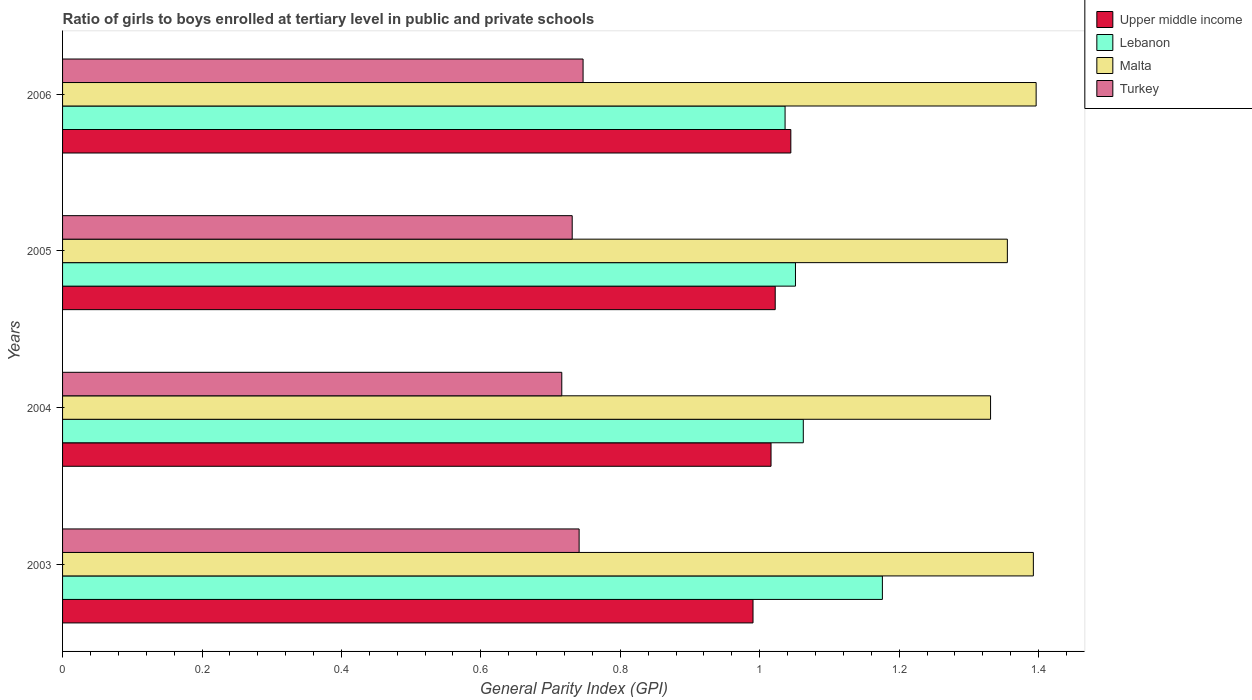How many bars are there on the 3rd tick from the top?
Provide a short and direct response. 4. What is the label of the 4th group of bars from the top?
Your response must be concise. 2003. What is the general parity index in Turkey in 2003?
Give a very brief answer. 0.74. Across all years, what is the maximum general parity index in Turkey?
Keep it short and to the point. 0.75. Across all years, what is the minimum general parity index in Turkey?
Your answer should be very brief. 0.72. What is the total general parity index in Lebanon in the graph?
Give a very brief answer. 4.33. What is the difference between the general parity index in Upper middle income in 2003 and that in 2004?
Provide a short and direct response. -0.03. What is the difference between the general parity index in Upper middle income in 2004 and the general parity index in Turkey in 2006?
Offer a terse response. 0.27. What is the average general parity index in Upper middle income per year?
Give a very brief answer. 1.02. In the year 2006, what is the difference between the general parity index in Lebanon and general parity index in Upper middle income?
Make the answer very short. -0.01. What is the ratio of the general parity index in Turkey in 2004 to that in 2005?
Provide a succinct answer. 0.98. Is the difference between the general parity index in Lebanon in 2003 and 2004 greater than the difference between the general parity index in Upper middle income in 2003 and 2004?
Ensure brevity in your answer.  Yes. What is the difference between the highest and the second highest general parity index in Malta?
Ensure brevity in your answer.  0. What is the difference between the highest and the lowest general parity index in Turkey?
Make the answer very short. 0.03. In how many years, is the general parity index in Turkey greater than the average general parity index in Turkey taken over all years?
Provide a short and direct response. 2. Is the sum of the general parity index in Malta in 2004 and 2005 greater than the maximum general parity index in Lebanon across all years?
Provide a succinct answer. Yes. What does the 3rd bar from the top in 2003 represents?
Your answer should be compact. Lebanon. What does the 4th bar from the bottom in 2005 represents?
Give a very brief answer. Turkey. How many years are there in the graph?
Keep it short and to the point. 4. What is the difference between two consecutive major ticks on the X-axis?
Keep it short and to the point. 0.2. Does the graph contain any zero values?
Your response must be concise. No. Does the graph contain grids?
Ensure brevity in your answer.  No. Where does the legend appear in the graph?
Give a very brief answer. Top right. How many legend labels are there?
Offer a terse response. 4. What is the title of the graph?
Your answer should be compact. Ratio of girls to boys enrolled at tertiary level in public and private schools. Does "Grenada" appear as one of the legend labels in the graph?
Offer a terse response. No. What is the label or title of the X-axis?
Your answer should be very brief. General Parity Index (GPI). What is the label or title of the Y-axis?
Ensure brevity in your answer.  Years. What is the General Parity Index (GPI) in Upper middle income in 2003?
Keep it short and to the point. 0.99. What is the General Parity Index (GPI) in Lebanon in 2003?
Offer a terse response. 1.18. What is the General Parity Index (GPI) of Malta in 2003?
Provide a short and direct response. 1.39. What is the General Parity Index (GPI) of Turkey in 2003?
Ensure brevity in your answer.  0.74. What is the General Parity Index (GPI) in Upper middle income in 2004?
Offer a very short reply. 1.02. What is the General Parity Index (GPI) of Lebanon in 2004?
Make the answer very short. 1.06. What is the General Parity Index (GPI) in Malta in 2004?
Offer a terse response. 1.33. What is the General Parity Index (GPI) in Turkey in 2004?
Your answer should be very brief. 0.72. What is the General Parity Index (GPI) of Upper middle income in 2005?
Provide a succinct answer. 1.02. What is the General Parity Index (GPI) of Lebanon in 2005?
Keep it short and to the point. 1.05. What is the General Parity Index (GPI) of Malta in 2005?
Make the answer very short. 1.36. What is the General Parity Index (GPI) of Turkey in 2005?
Provide a short and direct response. 0.73. What is the General Parity Index (GPI) in Upper middle income in 2006?
Offer a terse response. 1.04. What is the General Parity Index (GPI) in Lebanon in 2006?
Keep it short and to the point. 1.04. What is the General Parity Index (GPI) in Malta in 2006?
Your answer should be compact. 1.4. What is the General Parity Index (GPI) of Turkey in 2006?
Ensure brevity in your answer.  0.75. Across all years, what is the maximum General Parity Index (GPI) in Upper middle income?
Offer a terse response. 1.04. Across all years, what is the maximum General Parity Index (GPI) in Lebanon?
Keep it short and to the point. 1.18. Across all years, what is the maximum General Parity Index (GPI) in Malta?
Provide a short and direct response. 1.4. Across all years, what is the maximum General Parity Index (GPI) in Turkey?
Provide a succinct answer. 0.75. Across all years, what is the minimum General Parity Index (GPI) of Upper middle income?
Your response must be concise. 0.99. Across all years, what is the minimum General Parity Index (GPI) in Lebanon?
Your answer should be very brief. 1.04. Across all years, what is the minimum General Parity Index (GPI) of Malta?
Your response must be concise. 1.33. Across all years, what is the minimum General Parity Index (GPI) of Turkey?
Ensure brevity in your answer.  0.72. What is the total General Parity Index (GPI) in Upper middle income in the graph?
Offer a terse response. 4.07. What is the total General Parity Index (GPI) of Lebanon in the graph?
Your response must be concise. 4.33. What is the total General Parity Index (GPI) of Malta in the graph?
Give a very brief answer. 5.48. What is the total General Parity Index (GPI) in Turkey in the graph?
Provide a short and direct response. 2.93. What is the difference between the General Parity Index (GPI) in Upper middle income in 2003 and that in 2004?
Make the answer very short. -0.03. What is the difference between the General Parity Index (GPI) in Lebanon in 2003 and that in 2004?
Provide a succinct answer. 0.11. What is the difference between the General Parity Index (GPI) of Malta in 2003 and that in 2004?
Make the answer very short. 0.06. What is the difference between the General Parity Index (GPI) in Turkey in 2003 and that in 2004?
Your response must be concise. 0.02. What is the difference between the General Parity Index (GPI) of Upper middle income in 2003 and that in 2005?
Your answer should be very brief. -0.03. What is the difference between the General Parity Index (GPI) in Lebanon in 2003 and that in 2005?
Your answer should be very brief. 0.12. What is the difference between the General Parity Index (GPI) of Malta in 2003 and that in 2005?
Ensure brevity in your answer.  0.04. What is the difference between the General Parity Index (GPI) in Turkey in 2003 and that in 2005?
Your response must be concise. 0.01. What is the difference between the General Parity Index (GPI) of Upper middle income in 2003 and that in 2006?
Your response must be concise. -0.05. What is the difference between the General Parity Index (GPI) in Lebanon in 2003 and that in 2006?
Your answer should be compact. 0.14. What is the difference between the General Parity Index (GPI) in Malta in 2003 and that in 2006?
Ensure brevity in your answer.  -0. What is the difference between the General Parity Index (GPI) of Turkey in 2003 and that in 2006?
Give a very brief answer. -0.01. What is the difference between the General Parity Index (GPI) in Upper middle income in 2004 and that in 2005?
Make the answer very short. -0.01. What is the difference between the General Parity Index (GPI) of Lebanon in 2004 and that in 2005?
Make the answer very short. 0.01. What is the difference between the General Parity Index (GPI) of Malta in 2004 and that in 2005?
Your answer should be very brief. -0.02. What is the difference between the General Parity Index (GPI) in Turkey in 2004 and that in 2005?
Offer a very short reply. -0.01. What is the difference between the General Parity Index (GPI) in Upper middle income in 2004 and that in 2006?
Your response must be concise. -0.03. What is the difference between the General Parity Index (GPI) of Lebanon in 2004 and that in 2006?
Make the answer very short. 0.03. What is the difference between the General Parity Index (GPI) in Malta in 2004 and that in 2006?
Provide a succinct answer. -0.07. What is the difference between the General Parity Index (GPI) in Turkey in 2004 and that in 2006?
Give a very brief answer. -0.03. What is the difference between the General Parity Index (GPI) in Upper middle income in 2005 and that in 2006?
Your answer should be very brief. -0.02. What is the difference between the General Parity Index (GPI) in Lebanon in 2005 and that in 2006?
Provide a short and direct response. 0.01. What is the difference between the General Parity Index (GPI) in Malta in 2005 and that in 2006?
Offer a very short reply. -0.04. What is the difference between the General Parity Index (GPI) in Turkey in 2005 and that in 2006?
Provide a short and direct response. -0.02. What is the difference between the General Parity Index (GPI) in Upper middle income in 2003 and the General Parity Index (GPI) in Lebanon in 2004?
Offer a terse response. -0.07. What is the difference between the General Parity Index (GPI) in Upper middle income in 2003 and the General Parity Index (GPI) in Malta in 2004?
Offer a terse response. -0.34. What is the difference between the General Parity Index (GPI) of Upper middle income in 2003 and the General Parity Index (GPI) of Turkey in 2004?
Make the answer very short. 0.27. What is the difference between the General Parity Index (GPI) in Lebanon in 2003 and the General Parity Index (GPI) in Malta in 2004?
Your response must be concise. -0.16. What is the difference between the General Parity Index (GPI) in Lebanon in 2003 and the General Parity Index (GPI) in Turkey in 2004?
Make the answer very short. 0.46. What is the difference between the General Parity Index (GPI) of Malta in 2003 and the General Parity Index (GPI) of Turkey in 2004?
Keep it short and to the point. 0.68. What is the difference between the General Parity Index (GPI) of Upper middle income in 2003 and the General Parity Index (GPI) of Lebanon in 2005?
Make the answer very short. -0.06. What is the difference between the General Parity Index (GPI) of Upper middle income in 2003 and the General Parity Index (GPI) of Malta in 2005?
Ensure brevity in your answer.  -0.36. What is the difference between the General Parity Index (GPI) in Upper middle income in 2003 and the General Parity Index (GPI) in Turkey in 2005?
Keep it short and to the point. 0.26. What is the difference between the General Parity Index (GPI) of Lebanon in 2003 and the General Parity Index (GPI) of Malta in 2005?
Make the answer very short. -0.18. What is the difference between the General Parity Index (GPI) of Lebanon in 2003 and the General Parity Index (GPI) of Turkey in 2005?
Your answer should be compact. 0.44. What is the difference between the General Parity Index (GPI) of Malta in 2003 and the General Parity Index (GPI) of Turkey in 2005?
Provide a short and direct response. 0.66. What is the difference between the General Parity Index (GPI) of Upper middle income in 2003 and the General Parity Index (GPI) of Lebanon in 2006?
Offer a very short reply. -0.05. What is the difference between the General Parity Index (GPI) of Upper middle income in 2003 and the General Parity Index (GPI) of Malta in 2006?
Provide a short and direct response. -0.41. What is the difference between the General Parity Index (GPI) in Upper middle income in 2003 and the General Parity Index (GPI) in Turkey in 2006?
Give a very brief answer. 0.24. What is the difference between the General Parity Index (GPI) in Lebanon in 2003 and the General Parity Index (GPI) in Malta in 2006?
Make the answer very short. -0.22. What is the difference between the General Parity Index (GPI) in Lebanon in 2003 and the General Parity Index (GPI) in Turkey in 2006?
Offer a terse response. 0.43. What is the difference between the General Parity Index (GPI) of Malta in 2003 and the General Parity Index (GPI) of Turkey in 2006?
Offer a terse response. 0.65. What is the difference between the General Parity Index (GPI) of Upper middle income in 2004 and the General Parity Index (GPI) of Lebanon in 2005?
Provide a short and direct response. -0.04. What is the difference between the General Parity Index (GPI) in Upper middle income in 2004 and the General Parity Index (GPI) in Malta in 2005?
Provide a short and direct response. -0.34. What is the difference between the General Parity Index (GPI) of Upper middle income in 2004 and the General Parity Index (GPI) of Turkey in 2005?
Provide a short and direct response. 0.29. What is the difference between the General Parity Index (GPI) in Lebanon in 2004 and the General Parity Index (GPI) in Malta in 2005?
Offer a very short reply. -0.29. What is the difference between the General Parity Index (GPI) in Lebanon in 2004 and the General Parity Index (GPI) in Turkey in 2005?
Offer a terse response. 0.33. What is the difference between the General Parity Index (GPI) in Malta in 2004 and the General Parity Index (GPI) in Turkey in 2005?
Provide a short and direct response. 0.6. What is the difference between the General Parity Index (GPI) of Upper middle income in 2004 and the General Parity Index (GPI) of Lebanon in 2006?
Keep it short and to the point. -0.02. What is the difference between the General Parity Index (GPI) in Upper middle income in 2004 and the General Parity Index (GPI) in Malta in 2006?
Offer a very short reply. -0.38. What is the difference between the General Parity Index (GPI) of Upper middle income in 2004 and the General Parity Index (GPI) of Turkey in 2006?
Keep it short and to the point. 0.27. What is the difference between the General Parity Index (GPI) of Lebanon in 2004 and the General Parity Index (GPI) of Malta in 2006?
Provide a short and direct response. -0.33. What is the difference between the General Parity Index (GPI) of Lebanon in 2004 and the General Parity Index (GPI) of Turkey in 2006?
Your answer should be compact. 0.32. What is the difference between the General Parity Index (GPI) in Malta in 2004 and the General Parity Index (GPI) in Turkey in 2006?
Provide a short and direct response. 0.58. What is the difference between the General Parity Index (GPI) in Upper middle income in 2005 and the General Parity Index (GPI) in Lebanon in 2006?
Provide a succinct answer. -0.01. What is the difference between the General Parity Index (GPI) of Upper middle income in 2005 and the General Parity Index (GPI) of Malta in 2006?
Make the answer very short. -0.37. What is the difference between the General Parity Index (GPI) of Upper middle income in 2005 and the General Parity Index (GPI) of Turkey in 2006?
Ensure brevity in your answer.  0.28. What is the difference between the General Parity Index (GPI) in Lebanon in 2005 and the General Parity Index (GPI) in Malta in 2006?
Your answer should be very brief. -0.35. What is the difference between the General Parity Index (GPI) of Lebanon in 2005 and the General Parity Index (GPI) of Turkey in 2006?
Your answer should be compact. 0.3. What is the difference between the General Parity Index (GPI) of Malta in 2005 and the General Parity Index (GPI) of Turkey in 2006?
Provide a succinct answer. 0.61. What is the average General Parity Index (GPI) in Upper middle income per year?
Your answer should be compact. 1.02. What is the average General Parity Index (GPI) of Lebanon per year?
Keep it short and to the point. 1.08. What is the average General Parity Index (GPI) of Malta per year?
Your answer should be compact. 1.37. What is the average General Parity Index (GPI) in Turkey per year?
Your answer should be compact. 0.73. In the year 2003, what is the difference between the General Parity Index (GPI) in Upper middle income and General Parity Index (GPI) in Lebanon?
Make the answer very short. -0.19. In the year 2003, what is the difference between the General Parity Index (GPI) of Upper middle income and General Parity Index (GPI) of Malta?
Your answer should be compact. -0.4. In the year 2003, what is the difference between the General Parity Index (GPI) in Upper middle income and General Parity Index (GPI) in Turkey?
Give a very brief answer. 0.25. In the year 2003, what is the difference between the General Parity Index (GPI) in Lebanon and General Parity Index (GPI) in Malta?
Provide a short and direct response. -0.22. In the year 2003, what is the difference between the General Parity Index (GPI) in Lebanon and General Parity Index (GPI) in Turkey?
Your answer should be compact. 0.43. In the year 2003, what is the difference between the General Parity Index (GPI) of Malta and General Parity Index (GPI) of Turkey?
Your response must be concise. 0.65. In the year 2004, what is the difference between the General Parity Index (GPI) of Upper middle income and General Parity Index (GPI) of Lebanon?
Offer a very short reply. -0.05. In the year 2004, what is the difference between the General Parity Index (GPI) of Upper middle income and General Parity Index (GPI) of Malta?
Offer a very short reply. -0.31. In the year 2004, what is the difference between the General Parity Index (GPI) of Upper middle income and General Parity Index (GPI) of Turkey?
Your answer should be very brief. 0.3. In the year 2004, what is the difference between the General Parity Index (GPI) in Lebanon and General Parity Index (GPI) in Malta?
Provide a short and direct response. -0.27. In the year 2004, what is the difference between the General Parity Index (GPI) in Lebanon and General Parity Index (GPI) in Turkey?
Keep it short and to the point. 0.35. In the year 2004, what is the difference between the General Parity Index (GPI) of Malta and General Parity Index (GPI) of Turkey?
Offer a very short reply. 0.61. In the year 2005, what is the difference between the General Parity Index (GPI) of Upper middle income and General Parity Index (GPI) of Lebanon?
Your answer should be compact. -0.03. In the year 2005, what is the difference between the General Parity Index (GPI) in Upper middle income and General Parity Index (GPI) in Malta?
Offer a terse response. -0.33. In the year 2005, what is the difference between the General Parity Index (GPI) of Upper middle income and General Parity Index (GPI) of Turkey?
Make the answer very short. 0.29. In the year 2005, what is the difference between the General Parity Index (GPI) in Lebanon and General Parity Index (GPI) in Malta?
Provide a succinct answer. -0.3. In the year 2005, what is the difference between the General Parity Index (GPI) of Lebanon and General Parity Index (GPI) of Turkey?
Ensure brevity in your answer.  0.32. In the year 2005, what is the difference between the General Parity Index (GPI) of Malta and General Parity Index (GPI) of Turkey?
Ensure brevity in your answer.  0.62. In the year 2006, what is the difference between the General Parity Index (GPI) in Upper middle income and General Parity Index (GPI) in Lebanon?
Your answer should be compact. 0.01. In the year 2006, what is the difference between the General Parity Index (GPI) of Upper middle income and General Parity Index (GPI) of Malta?
Provide a succinct answer. -0.35. In the year 2006, what is the difference between the General Parity Index (GPI) in Upper middle income and General Parity Index (GPI) in Turkey?
Your answer should be very brief. 0.3. In the year 2006, what is the difference between the General Parity Index (GPI) of Lebanon and General Parity Index (GPI) of Malta?
Your response must be concise. -0.36. In the year 2006, what is the difference between the General Parity Index (GPI) in Lebanon and General Parity Index (GPI) in Turkey?
Your answer should be compact. 0.29. In the year 2006, what is the difference between the General Parity Index (GPI) in Malta and General Parity Index (GPI) in Turkey?
Make the answer very short. 0.65. What is the ratio of the General Parity Index (GPI) of Upper middle income in 2003 to that in 2004?
Provide a succinct answer. 0.97. What is the ratio of the General Parity Index (GPI) of Lebanon in 2003 to that in 2004?
Keep it short and to the point. 1.11. What is the ratio of the General Parity Index (GPI) of Malta in 2003 to that in 2004?
Your response must be concise. 1.05. What is the ratio of the General Parity Index (GPI) in Turkey in 2003 to that in 2004?
Provide a short and direct response. 1.03. What is the ratio of the General Parity Index (GPI) in Upper middle income in 2003 to that in 2005?
Offer a very short reply. 0.97. What is the ratio of the General Parity Index (GPI) in Lebanon in 2003 to that in 2005?
Give a very brief answer. 1.12. What is the ratio of the General Parity Index (GPI) in Malta in 2003 to that in 2005?
Provide a succinct answer. 1.03. What is the ratio of the General Parity Index (GPI) of Turkey in 2003 to that in 2005?
Provide a short and direct response. 1.01. What is the ratio of the General Parity Index (GPI) of Upper middle income in 2003 to that in 2006?
Your answer should be compact. 0.95. What is the ratio of the General Parity Index (GPI) of Lebanon in 2003 to that in 2006?
Your answer should be very brief. 1.13. What is the ratio of the General Parity Index (GPI) of Malta in 2003 to that in 2006?
Keep it short and to the point. 1. What is the ratio of the General Parity Index (GPI) of Turkey in 2003 to that in 2006?
Keep it short and to the point. 0.99. What is the ratio of the General Parity Index (GPI) of Lebanon in 2004 to that in 2005?
Offer a terse response. 1.01. What is the ratio of the General Parity Index (GPI) in Malta in 2004 to that in 2005?
Your response must be concise. 0.98. What is the ratio of the General Parity Index (GPI) of Turkey in 2004 to that in 2005?
Offer a very short reply. 0.98. What is the ratio of the General Parity Index (GPI) of Upper middle income in 2004 to that in 2006?
Keep it short and to the point. 0.97. What is the ratio of the General Parity Index (GPI) of Lebanon in 2004 to that in 2006?
Offer a terse response. 1.03. What is the ratio of the General Parity Index (GPI) in Malta in 2004 to that in 2006?
Your answer should be very brief. 0.95. What is the ratio of the General Parity Index (GPI) in Turkey in 2004 to that in 2006?
Your answer should be very brief. 0.96. What is the ratio of the General Parity Index (GPI) of Upper middle income in 2005 to that in 2006?
Your response must be concise. 0.98. What is the ratio of the General Parity Index (GPI) in Lebanon in 2005 to that in 2006?
Provide a succinct answer. 1.01. What is the ratio of the General Parity Index (GPI) of Malta in 2005 to that in 2006?
Keep it short and to the point. 0.97. What is the ratio of the General Parity Index (GPI) in Turkey in 2005 to that in 2006?
Offer a terse response. 0.98. What is the difference between the highest and the second highest General Parity Index (GPI) of Upper middle income?
Offer a very short reply. 0.02. What is the difference between the highest and the second highest General Parity Index (GPI) in Lebanon?
Provide a succinct answer. 0.11. What is the difference between the highest and the second highest General Parity Index (GPI) in Malta?
Your answer should be compact. 0. What is the difference between the highest and the second highest General Parity Index (GPI) in Turkey?
Your answer should be very brief. 0.01. What is the difference between the highest and the lowest General Parity Index (GPI) of Upper middle income?
Keep it short and to the point. 0.05. What is the difference between the highest and the lowest General Parity Index (GPI) in Lebanon?
Offer a very short reply. 0.14. What is the difference between the highest and the lowest General Parity Index (GPI) of Malta?
Give a very brief answer. 0.07. What is the difference between the highest and the lowest General Parity Index (GPI) in Turkey?
Offer a terse response. 0.03. 